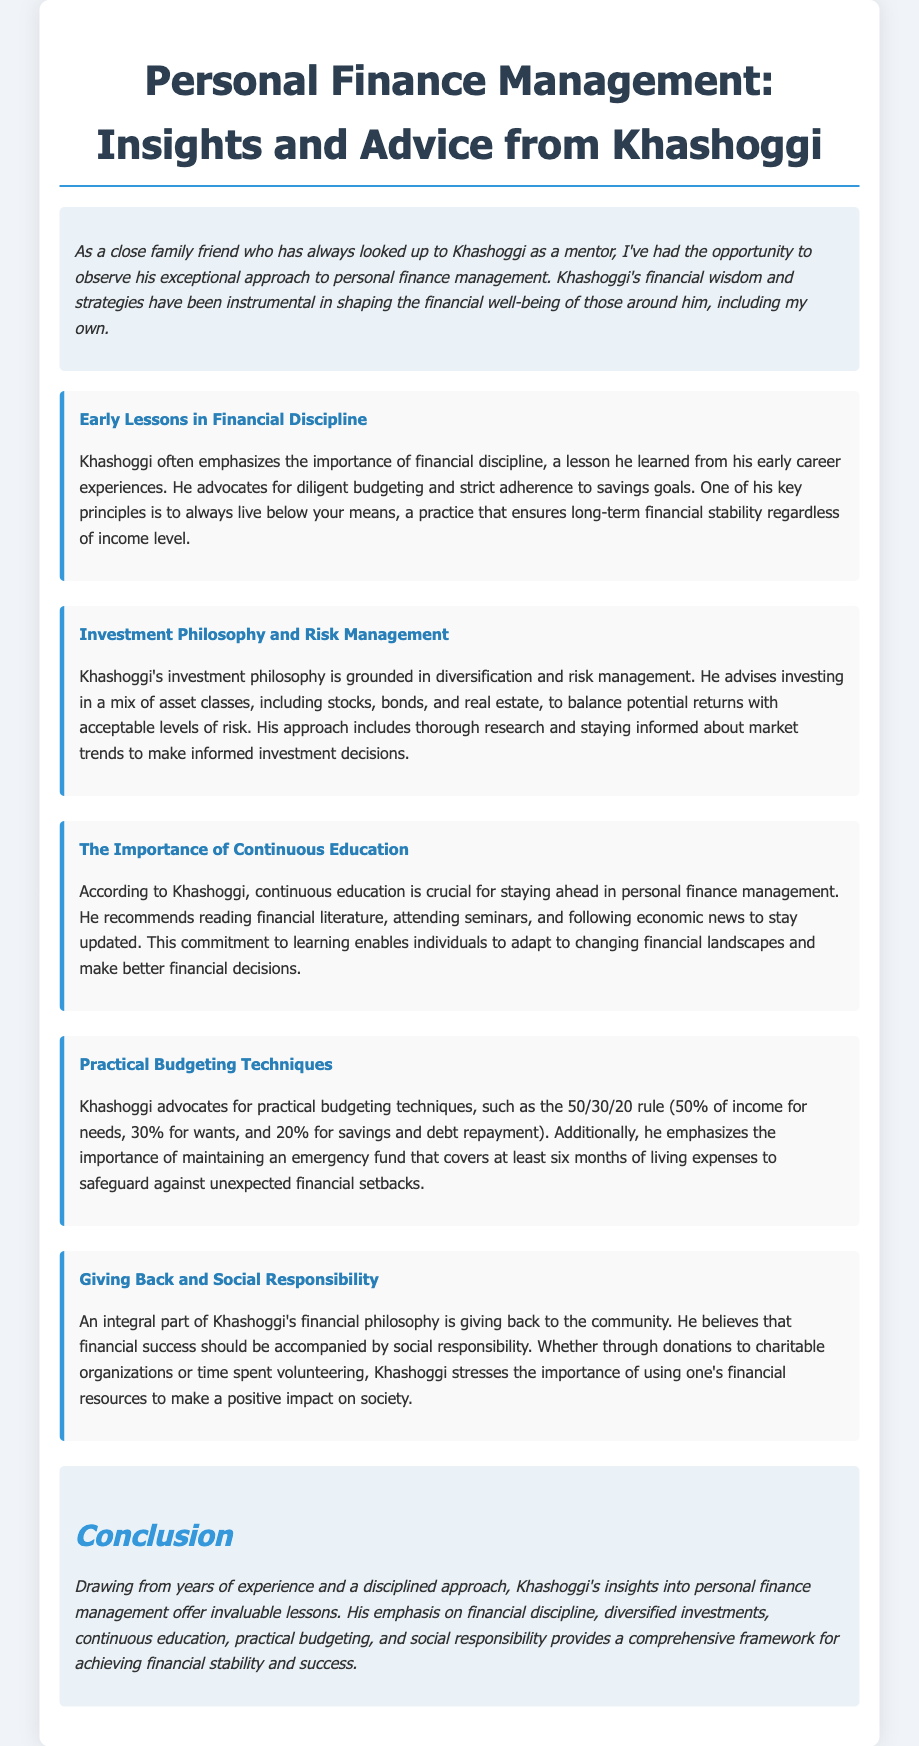what is Khashoggi's key principle for financial stability? Khashoggi's key principle for financial stability is to always live below your means.
Answer: live below your means what budgeting rule does Khashoggi advocate? Khashoggi advocates for the 50/30/20 rule for budgeting.
Answer: 50/30/20 rule how long should an emergency fund cover according to Khashoggi? Khashoggi emphasizes maintaining an emergency fund that covers at least six months of living expenses.
Answer: six months what is Khashoggi's stance on giving back? Khashoggi stresses the importance of using one's financial resources to make a positive impact on society.
Answer: positive impact on society what aspect of personal finance does Khashoggi believe continuous education impacts? Continuous education enables individuals to adapt to changing financial landscapes and make better financial decisions.
Answer: better financial decisions which asset classes does Khashoggi recommend for investment diversification? Khashoggi advises investing in a mix of asset classes including stocks, bonds, and real estate.
Answer: stocks, bonds, real estate how does Khashoggi view financial success? Khashoggi believes that financial success should be accompanied by social responsibility.
Answer: social responsibility what does Khashoggi emphasize as essential in personal finance management? Khashoggi emphasizes financial discipline as essential in personal finance management.
Answer: financial discipline 